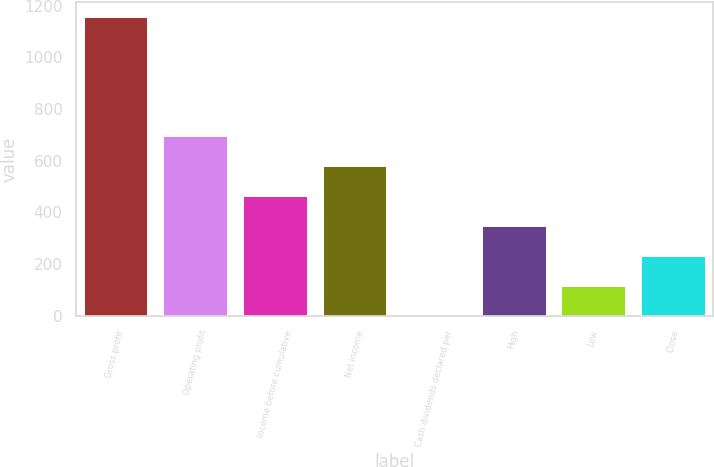<chart> <loc_0><loc_0><loc_500><loc_500><bar_chart><fcel>Gross profit<fcel>Operating profit<fcel>Income before cumulative<fcel>Net income<fcel>Cash dividends declared per<fcel>High<fcel>Low<fcel>Close<nl><fcel>1156.4<fcel>694.05<fcel>462.85<fcel>578.45<fcel>0.45<fcel>347.25<fcel>116.05<fcel>231.65<nl></chart> 